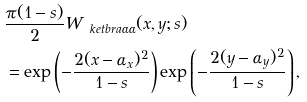Convert formula to latex. <formula><loc_0><loc_0><loc_500><loc_500>& \frac { \pi ( 1 - s ) } { 2 } W _ { \ k e t b r a { \alpha } { \alpha } } ( x , y ; s ) \\ & = \exp \left ( - \frac { 2 ( x - \alpha _ { x } ) ^ { 2 } } { 1 - s } \right ) \exp \left ( - \frac { 2 ( y - \alpha _ { y } ) ^ { 2 } } { 1 - s } \right ) ,</formula> 